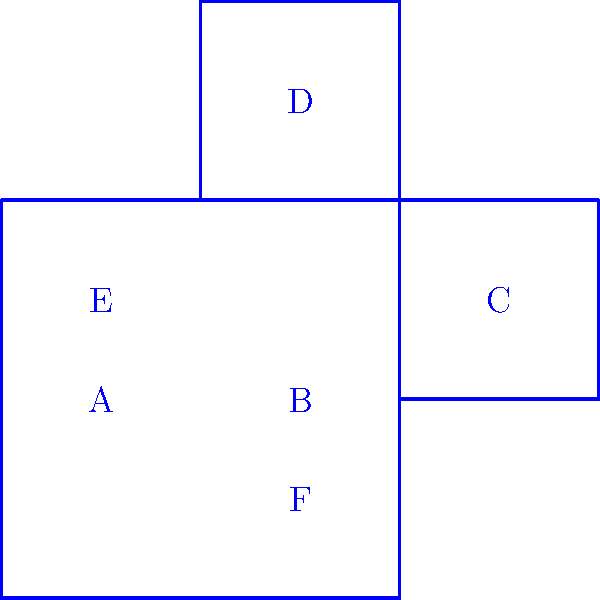In the context of spatial geometry, consider the 2D net and 3D shape shown above. If the net is folded to form the 3D shape, which face will be opposite to face A? To solve this problem, we need to mentally fold the net into the 3D shape. Let's follow these steps:

1. Identify the base: Face F will be the bottom of the cube.

2. Fold the sides:
   - Face A folds up to form the front face
   - Face B folds up to form the right face
   - Face C folds up to form the back face
   - Face E folds up to form the left face

3. Fold the top:
   - Face D folds to become the top face

4. Analyze the opposites:
   - Face A (front) is opposite to Face C (back)
   - Face B (right) is opposite to Face E (left)
   - Face F (bottom) is opposite to Face D (top)

Therefore, the face opposite to Face A is Face C.

This spatial reasoning exercise relates to the Indian philosophical concept of "drishti" or perspective, reminding us that our perception of reality can change based on our viewpoint, much like how the 2D net transforms into a 3D shape.
Answer: C 